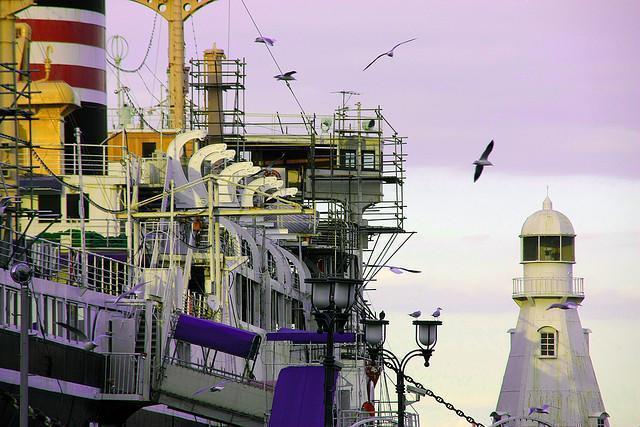How many kind of ships available mostly?
From the following set of four choices, select the accurate answer to respond to the question.
Options: Three, two, seven, four. Seven. 